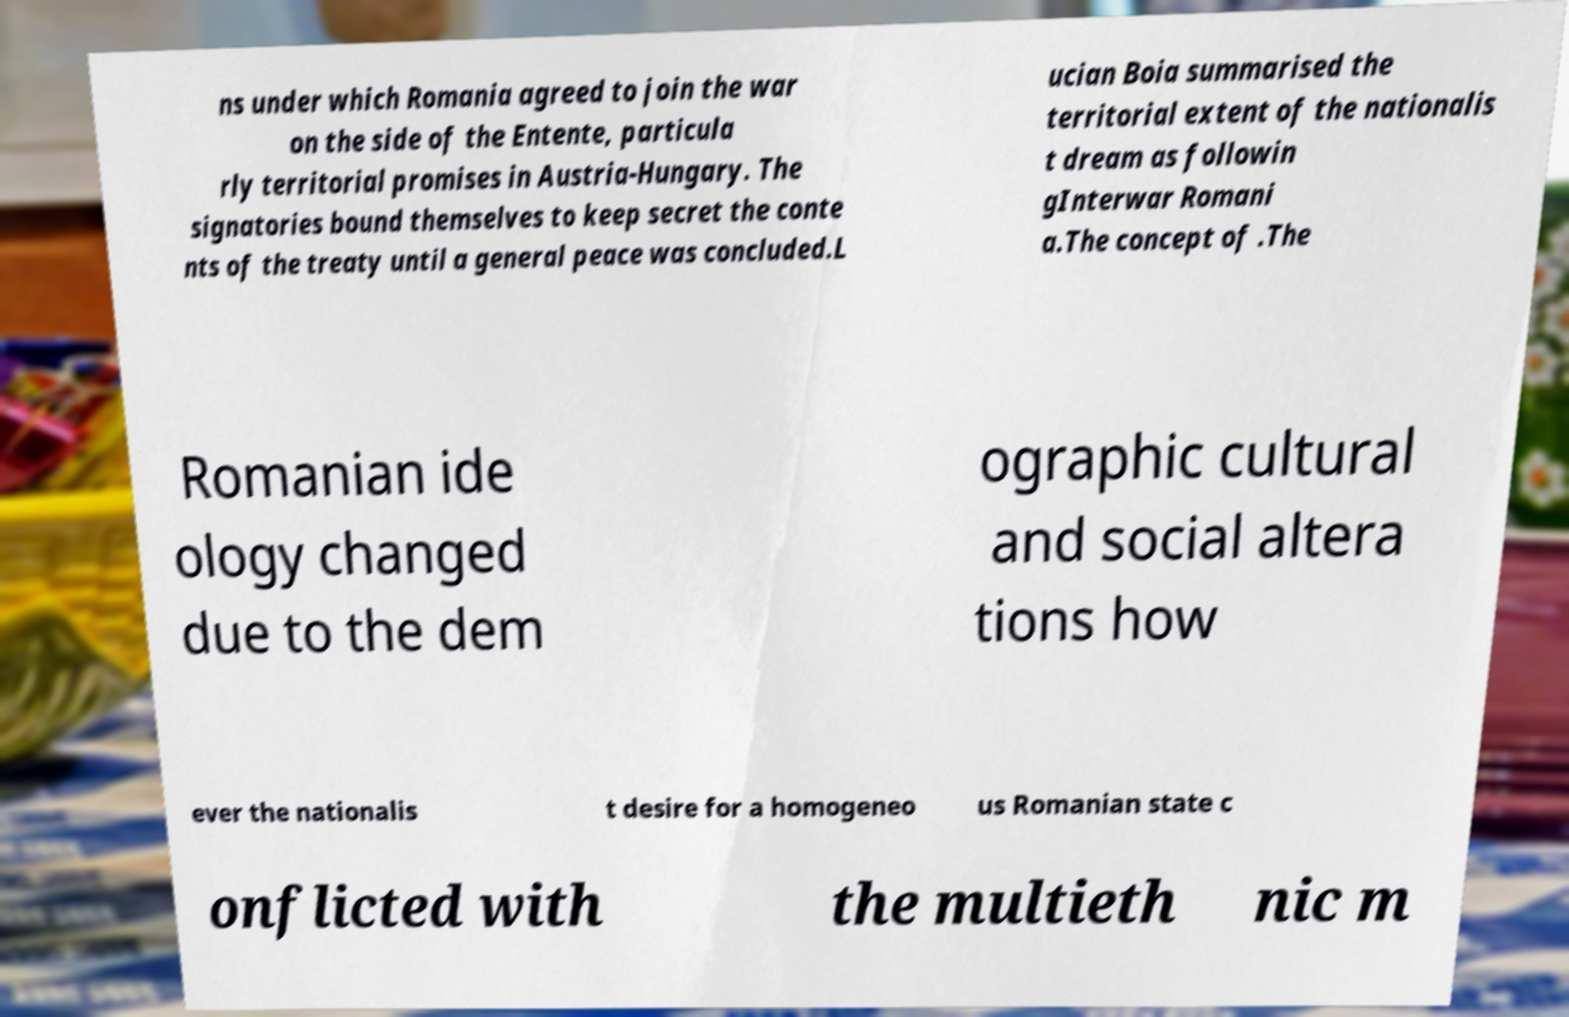Could you extract and type out the text from this image? ns under which Romania agreed to join the war on the side of the Entente, particula rly territorial promises in Austria-Hungary. The signatories bound themselves to keep secret the conte nts of the treaty until a general peace was concluded.L ucian Boia summarised the territorial extent of the nationalis t dream as followin gInterwar Romani a.The concept of .The Romanian ide ology changed due to the dem ographic cultural and social altera tions how ever the nationalis t desire for a homogeneo us Romanian state c onflicted with the multieth nic m 